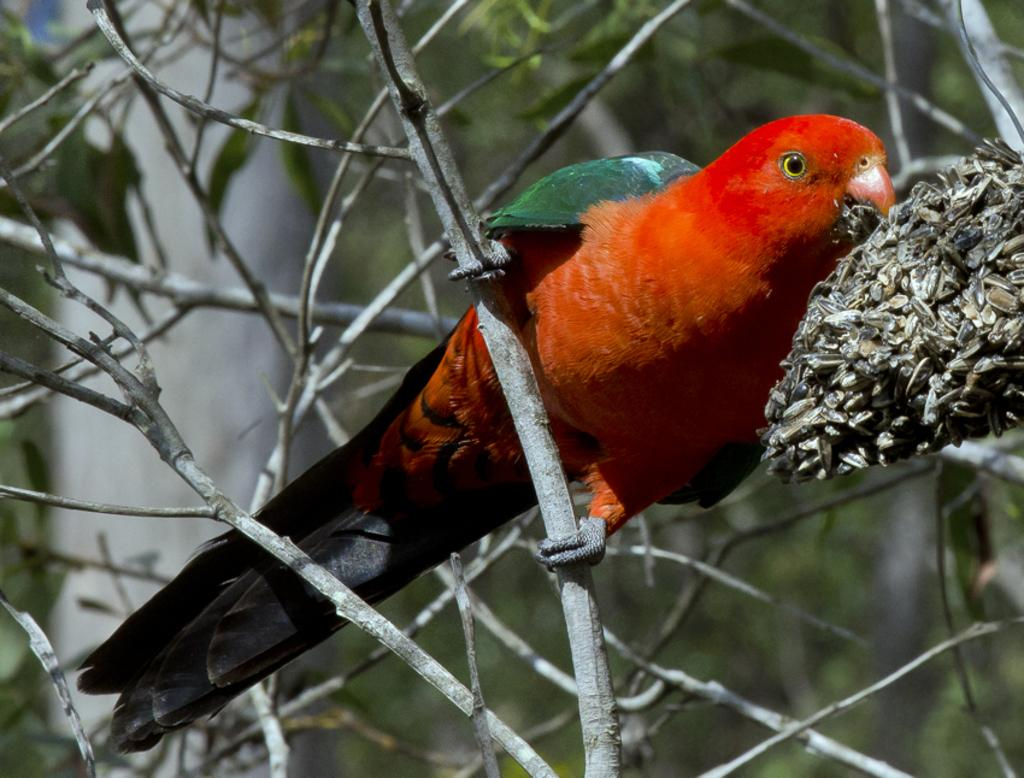What type of animal is in the image? There is a parrot in the image. Where is the parrot located? The parrot is on a branch of a tree. What can be seen in the background of the image? There are green leaves visible in the image. What type of music is the band playing in the background of the image? There is no band present in the image, so it is not possible to determine what type of music they might be playing. 